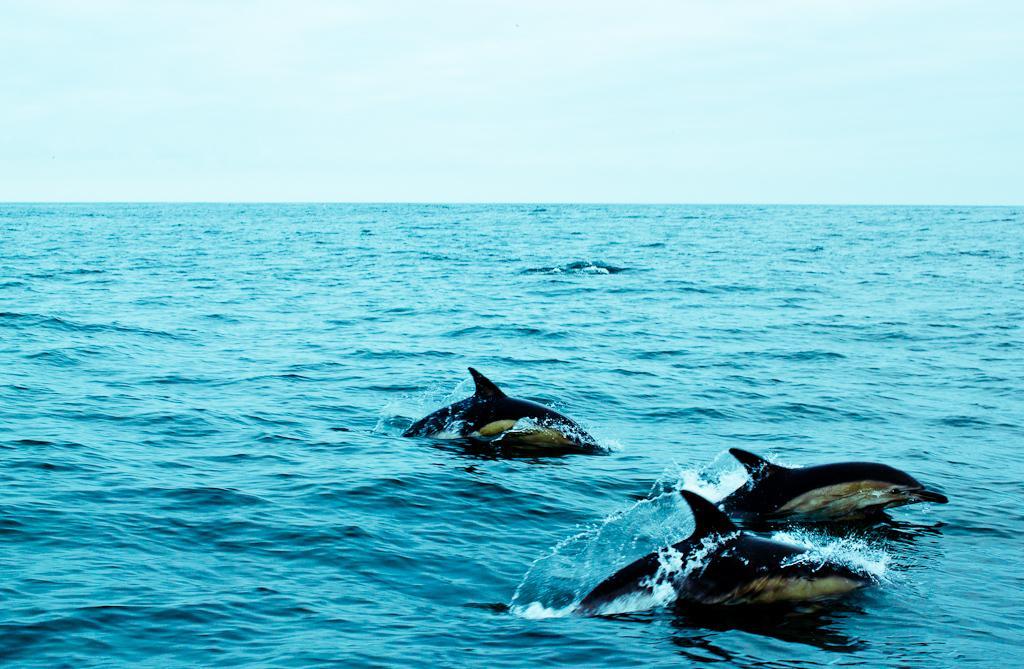Could you give a brief overview of what you see in this image? This picture shows few dolphins in the water and a cloudy Sky. 